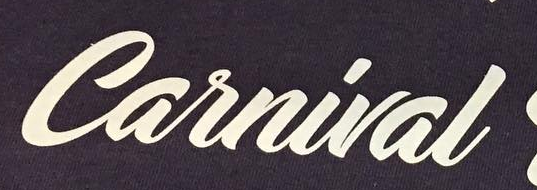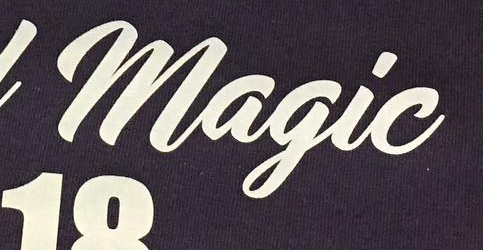Transcribe the words shown in these images in order, separated by a semicolon. Carnival; Magic 